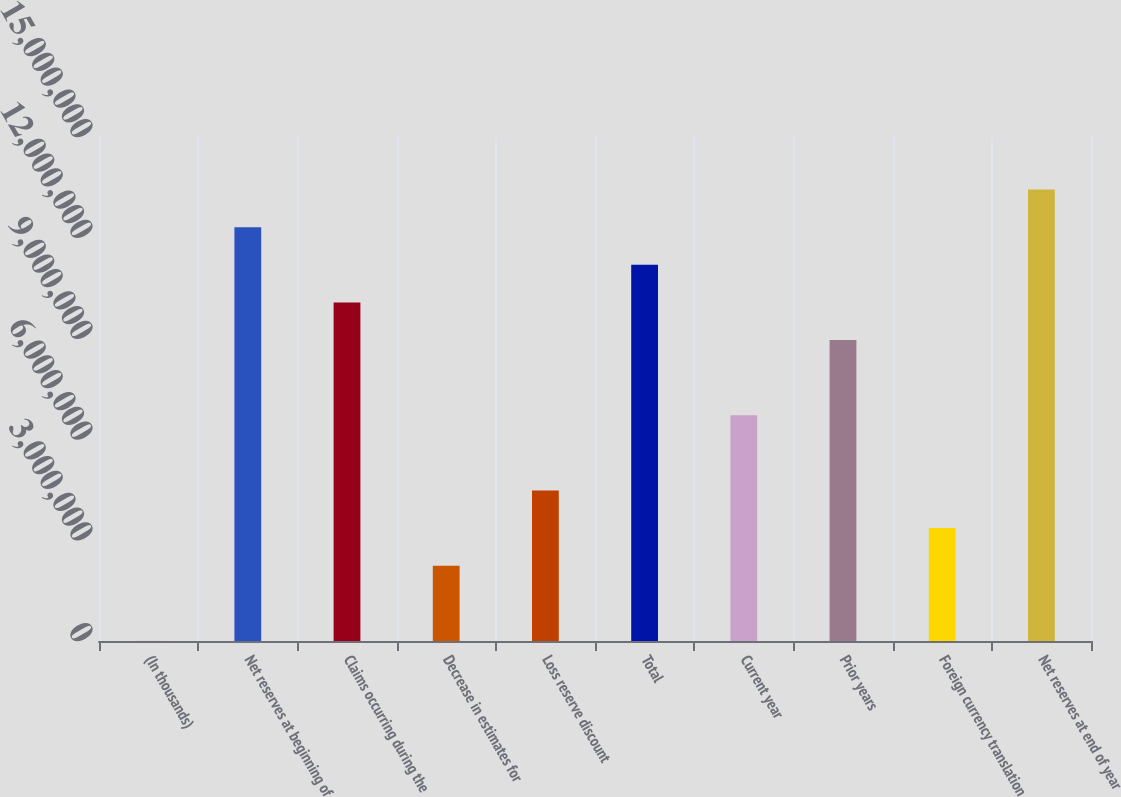<chart> <loc_0><loc_0><loc_500><loc_500><bar_chart><fcel>(In thousands)<fcel>Net reserves at beginning of<fcel>Claims occurring during the<fcel>Decrease in estimates for<fcel>Loss reserve discount<fcel>Total<fcel>Current year<fcel>Prior years<fcel>Foreign currency translation<fcel>Net reserves at end of year<nl><fcel>2016<fcel>1.23167e+07<fcel>1.00777e+07<fcel>2.24105e+06<fcel>4.48009e+06<fcel>1.11972e+07<fcel>6.71912e+06<fcel>8.95816e+06<fcel>3.36057e+06<fcel>1.34362e+07<nl></chart> 